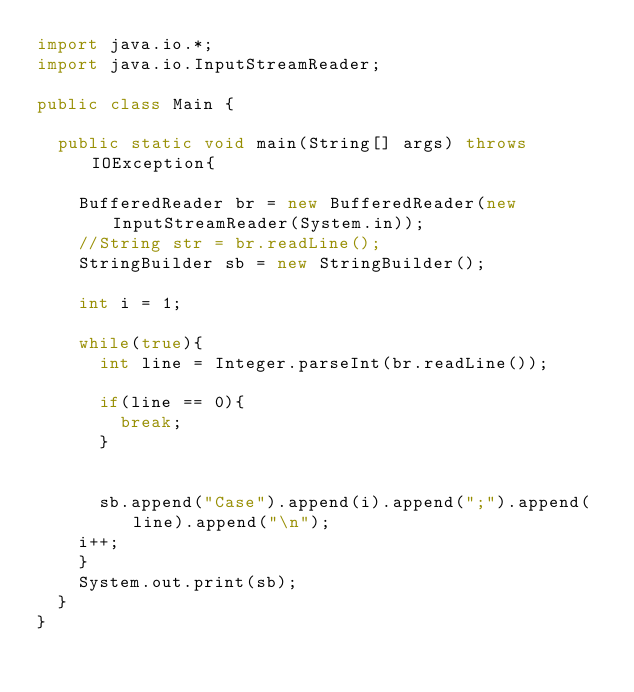Convert code to text. <code><loc_0><loc_0><loc_500><loc_500><_Java_>import java.io.*;
import java.io.InputStreamReader;

public class Main {

	public static void main(String[] args) throws IOException{
		
		BufferedReader br = new BufferedReader(new InputStreamReader(System.in));
		//String str = br.readLine();
		StringBuilder sb = new StringBuilder();
		
		int i = 1;
			
		while(true){
			int line = Integer.parseInt(br.readLine());
			
			if(line == 0){
				break;
			}
			
			
			sb.append("Case").append(i).append(";").append(line).append("\n");
		i++;
		}
		System.out.print(sb);
	}
}</code> 